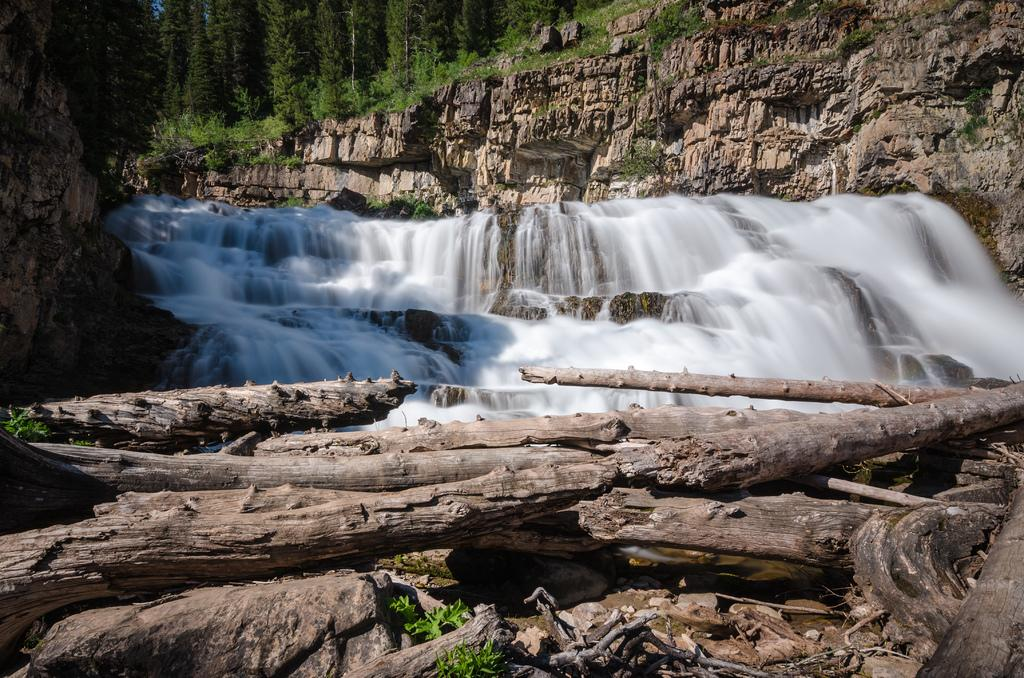What is the main feature in the center of the image? There is a waterfall in the center of the image. What can be seen at the bottom of the image? There are wooden sticks at the bottom of the image. What type of landscape is visible in the background of the image? There are mountains and trees in the background of the image. What type of oatmeal is stored in the drawer in the image? There is no drawer or oatmeal present in the image. 